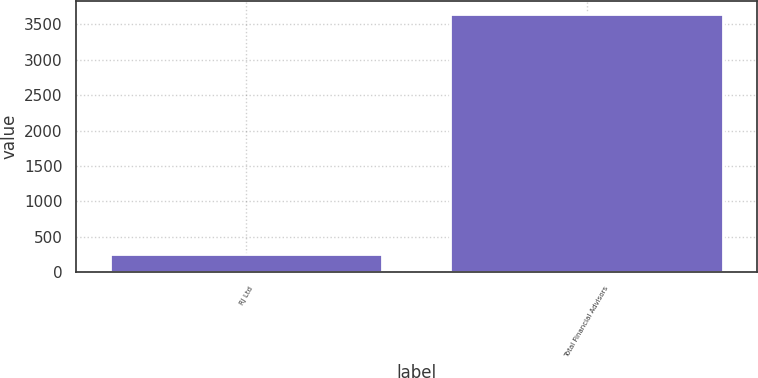<chart> <loc_0><loc_0><loc_500><loc_500><bar_chart><fcel>RJ Ltd<fcel>Total Financial Advisors<nl><fcel>257<fcel>3651<nl></chart> 